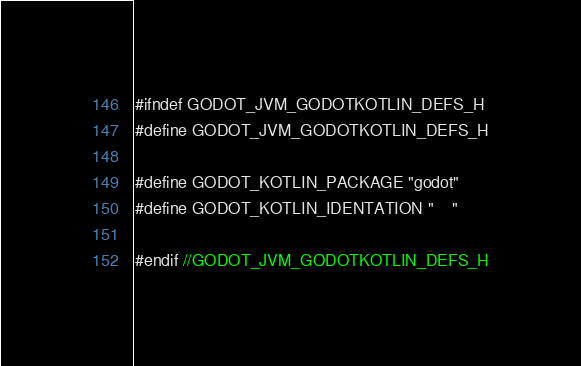Convert code to text. <code><loc_0><loc_0><loc_500><loc_500><_C_>#ifndef GODOT_JVM_GODOTKOTLIN_DEFS_H
#define GODOT_JVM_GODOTKOTLIN_DEFS_H

#define GODOT_KOTLIN_PACKAGE "godot"
#define GODOT_KOTLIN_IDENTATION "    "

#endif //GODOT_JVM_GODOTKOTLIN_DEFS_H
</code> 